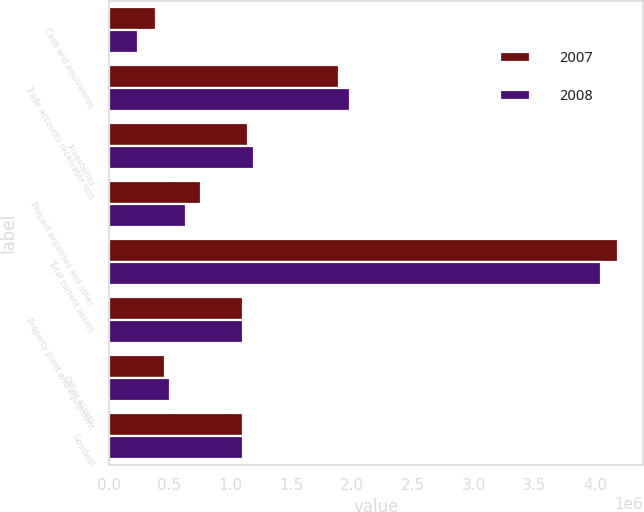Convert chart to OTSL. <chart><loc_0><loc_0><loc_500><loc_500><stacked_bar_chart><ecel><fcel>Cash and equivalents<fcel>Trade accounts receivable less<fcel>Inventories<fcel>Prepaid expenses and other<fcel>Total current assets<fcel>Property plant and equipment<fcel>Other assets<fcel>Goodwill<nl><fcel>2007<fcel>392854<fcel>1.89458e+06<fcel>1.14231e+06<fcel>757371<fcel>4.18712e+06<fcel>1.10865e+06<fcel>464353<fcel>1.10864e+06<nl><fcel>2008<fcel>239108<fcel>1.98438e+06<fcel>1.19362e+06<fcel>632660<fcel>4.04977e+06<fcel>1.10863e+06<fcel>507550<fcel>1.10864e+06<nl></chart> 